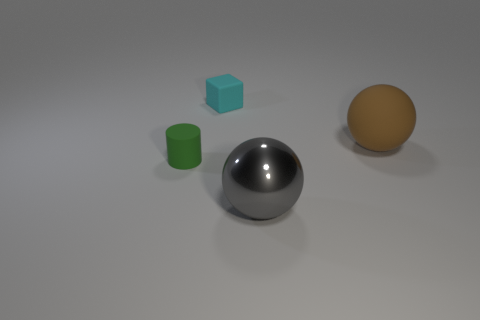Are the large brown ball and the small green object made of the same material?
Provide a succinct answer. Yes. How many other objects are the same material as the big gray thing?
Offer a very short reply. 0. What number of things are both on the left side of the big rubber object and in front of the small rubber cube?
Give a very brief answer. 2. The big shiny object has what color?
Your answer should be compact. Gray. There is another large object that is the same shape as the big gray metal object; what is it made of?
Provide a short and direct response. Rubber. Is there anything else that has the same material as the gray object?
Make the answer very short. No. Is the tiny matte cylinder the same color as the rubber ball?
Give a very brief answer. No. There is a big thing right of the big sphere in front of the tiny green rubber cylinder; what shape is it?
Provide a short and direct response. Sphere. There is a cyan object that is the same material as the large brown ball; what shape is it?
Provide a succinct answer. Cube. How many other things are there of the same shape as the brown object?
Ensure brevity in your answer.  1. 